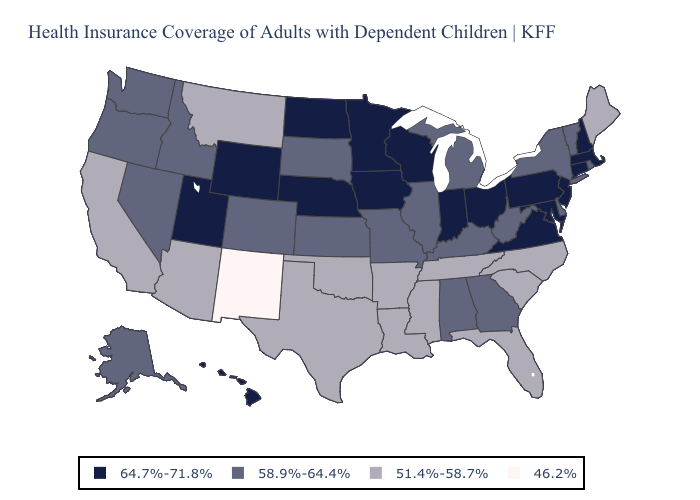Does New Mexico have the lowest value in the USA?
Write a very short answer. Yes. Name the states that have a value in the range 46.2%?
Concise answer only. New Mexico. Among the states that border Wyoming , which have the highest value?
Answer briefly. Nebraska, Utah. Name the states that have a value in the range 64.7%-71.8%?
Give a very brief answer. Connecticut, Hawaii, Indiana, Iowa, Maryland, Massachusetts, Minnesota, Nebraska, New Hampshire, New Jersey, North Dakota, Ohio, Pennsylvania, Utah, Virginia, Wisconsin, Wyoming. What is the value of Indiana?
Quick response, please. 64.7%-71.8%. What is the value of North Dakota?
Quick response, please. 64.7%-71.8%. Name the states that have a value in the range 46.2%?
Short answer required. New Mexico. Does Ohio have the same value as Arkansas?
Be succinct. No. What is the value of Connecticut?
Give a very brief answer. 64.7%-71.8%. Does North Dakota have the highest value in the USA?
Answer briefly. Yes. How many symbols are there in the legend?
Short answer required. 4. Name the states that have a value in the range 58.9%-64.4%?
Give a very brief answer. Alabama, Alaska, Colorado, Delaware, Georgia, Idaho, Illinois, Kansas, Kentucky, Michigan, Missouri, Nevada, New York, Oregon, Rhode Island, South Dakota, Vermont, Washington, West Virginia. Does the first symbol in the legend represent the smallest category?
Answer briefly. No. Name the states that have a value in the range 46.2%?
Give a very brief answer. New Mexico. Name the states that have a value in the range 64.7%-71.8%?
Write a very short answer. Connecticut, Hawaii, Indiana, Iowa, Maryland, Massachusetts, Minnesota, Nebraska, New Hampshire, New Jersey, North Dakota, Ohio, Pennsylvania, Utah, Virginia, Wisconsin, Wyoming. 